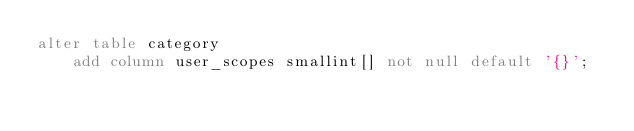<code> <loc_0><loc_0><loc_500><loc_500><_SQL_>alter table category 
    add column user_scopes smallint[] not null default '{}';
</code> 